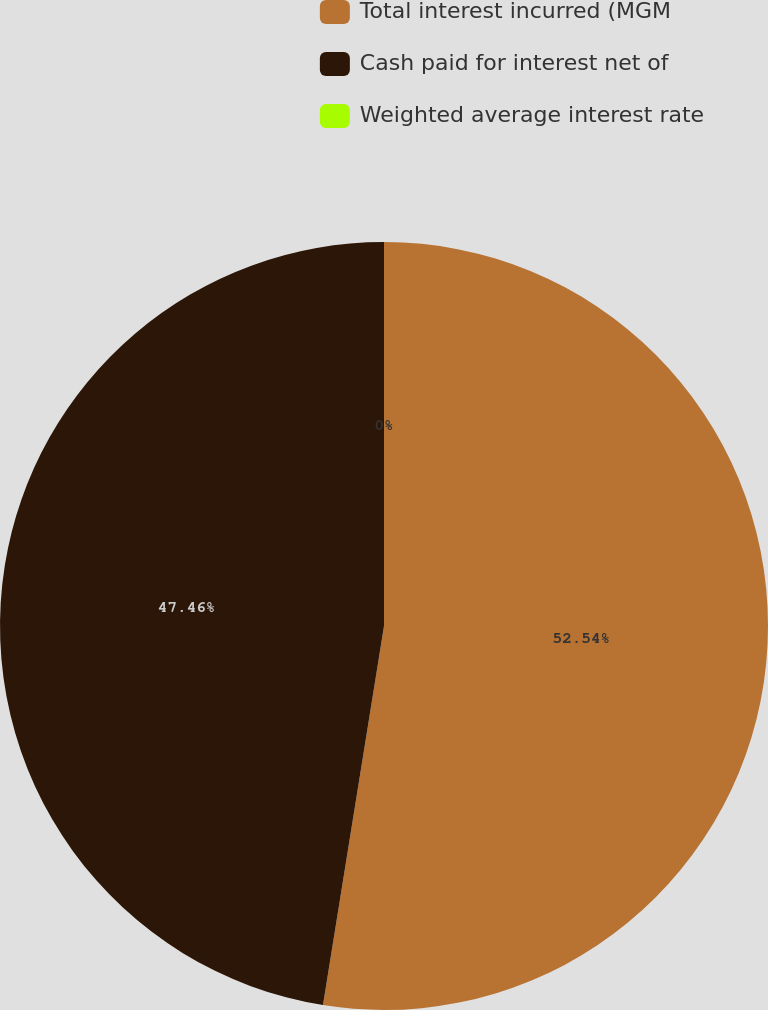Convert chart to OTSL. <chart><loc_0><loc_0><loc_500><loc_500><pie_chart><fcel>Total interest incurred (MGM<fcel>Cash paid for interest net of<fcel>Weighted average interest rate<nl><fcel>52.54%<fcel>47.46%<fcel>0.0%<nl></chart> 